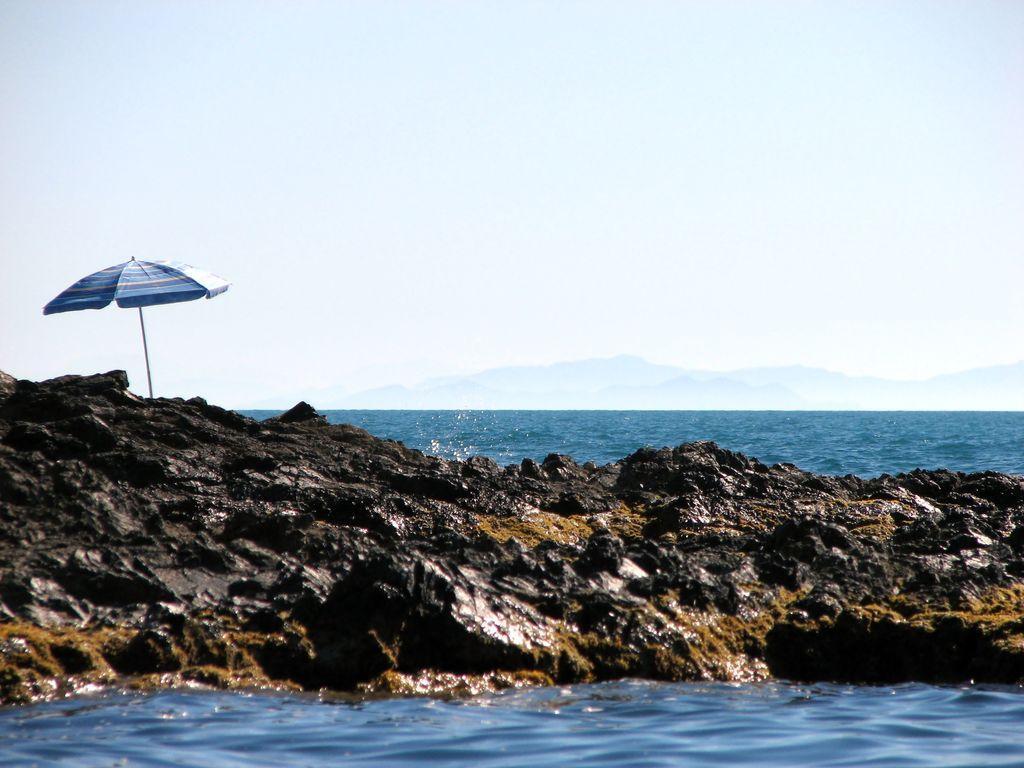Describe this image in one or two sentences. On the left side of the image there is a parasol. In the center we can see rocks. In the background there is a sea, hill and sky. 